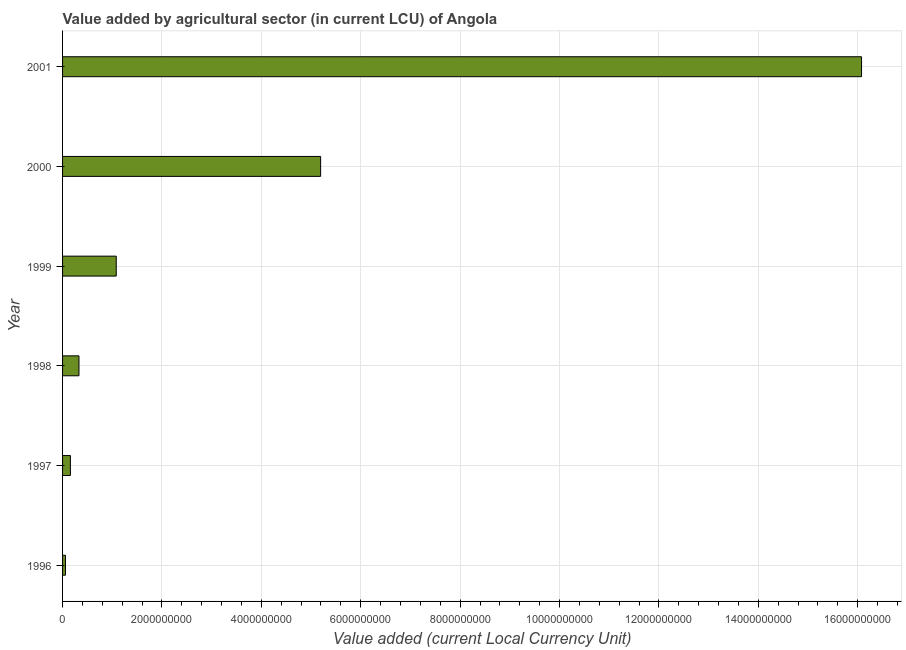Does the graph contain any zero values?
Provide a short and direct response. No. Does the graph contain grids?
Keep it short and to the point. Yes. What is the title of the graph?
Offer a terse response. Value added by agricultural sector (in current LCU) of Angola. What is the label or title of the X-axis?
Give a very brief answer. Value added (current Local Currency Unit). What is the value added by agriculture sector in 2001?
Your response must be concise. 1.61e+1. Across all years, what is the maximum value added by agriculture sector?
Your answer should be very brief. 1.61e+1. Across all years, what is the minimum value added by agriculture sector?
Provide a short and direct response. 5.87e+07. In which year was the value added by agriculture sector minimum?
Your response must be concise. 1996. What is the sum of the value added by agriculture sector?
Provide a succinct answer. 2.29e+1. What is the difference between the value added by agriculture sector in 1998 and 2001?
Your answer should be compact. -1.57e+1. What is the average value added by agriculture sector per year?
Your response must be concise. 3.82e+09. What is the median value added by agriculture sector?
Your answer should be very brief. 7.05e+08. What is the ratio of the value added by agriculture sector in 1996 to that in 1998?
Give a very brief answer. 0.18. What is the difference between the highest and the second highest value added by agriculture sector?
Keep it short and to the point. 1.09e+1. Is the sum of the value added by agriculture sector in 1996 and 2001 greater than the maximum value added by agriculture sector across all years?
Offer a terse response. Yes. What is the difference between the highest and the lowest value added by agriculture sector?
Provide a succinct answer. 1.60e+1. Are the values on the major ticks of X-axis written in scientific E-notation?
Offer a terse response. No. What is the Value added (current Local Currency Unit) of 1996?
Ensure brevity in your answer.  5.87e+07. What is the Value added (current Local Currency Unit) of 1997?
Offer a very short reply. 1.58e+08. What is the Value added (current Local Currency Unit) of 1998?
Offer a very short reply. 3.30e+08. What is the Value added (current Local Currency Unit) in 1999?
Ensure brevity in your answer.  1.08e+09. What is the Value added (current Local Currency Unit) in 2000?
Your answer should be compact. 5.19e+09. What is the Value added (current Local Currency Unit) in 2001?
Provide a short and direct response. 1.61e+1. What is the difference between the Value added (current Local Currency Unit) in 1996 and 1997?
Your answer should be very brief. -9.90e+07. What is the difference between the Value added (current Local Currency Unit) in 1996 and 1998?
Give a very brief answer. -2.71e+08. What is the difference between the Value added (current Local Currency Unit) in 1996 and 1999?
Give a very brief answer. -1.02e+09. What is the difference between the Value added (current Local Currency Unit) in 1996 and 2000?
Offer a terse response. -5.13e+09. What is the difference between the Value added (current Local Currency Unit) in 1996 and 2001?
Offer a terse response. -1.60e+1. What is the difference between the Value added (current Local Currency Unit) in 1997 and 1998?
Provide a short and direct response. -1.72e+08. What is the difference between the Value added (current Local Currency Unit) in 1997 and 1999?
Provide a succinct answer. -9.22e+08. What is the difference between the Value added (current Local Currency Unit) in 1997 and 2000?
Your answer should be compact. -5.03e+09. What is the difference between the Value added (current Local Currency Unit) in 1997 and 2001?
Keep it short and to the point. -1.59e+1. What is the difference between the Value added (current Local Currency Unit) in 1998 and 1999?
Provide a succinct answer. -7.50e+08. What is the difference between the Value added (current Local Currency Unit) in 1998 and 2000?
Provide a short and direct response. -4.86e+09. What is the difference between the Value added (current Local Currency Unit) in 1998 and 2001?
Keep it short and to the point. -1.57e+1. What is the difference between the Value added (current Local Currency Unit) in 1999 and 2000?
Your response must be concise. -4.11e+09. What is the difference between the Value added (current Local Currency Unit) in 1999 and 2001?
Your answer should be compact. -1.50e+1. What is the difference between the Value added (current Local Currency Unit) in 2000 and 2001?
Keep it short and to the point. -1.09e+1. What is the ratio of the Value added (current Local Currency Unit) in 1996 to that in 1997?
Make the answer very short. 0.37. What is the ratio of the Value added (current Local Currency Unit) in 1996 to that in 1998?
Offer a terse response. 0.18. What is the ratio of the Value added (current Local Currency Unit) in 1996 to that in 1999?
Your answer should be very brief. 0.05. What is the ratio of the Value added (current Local Currency Unit) in 1996 to that in 2000?
Your answer should be very brief. 0.01. What is the ratio of the Value added (current Local Currency Unit) in 1996 to that in 2001?
Offer a terse response. 0. What is the ratio of the Value added (current Local Currency Unit) in 1997 to that in 1998?
Make the answer very short. 0.48. What is the ratio of the Value added (current Local Currency Unit) in 1997 to that in 1999?
Offer a very short reply. 0.15. What is the ratio of the Value added (current Local Currency Unit) in 1997 to that in 2000?
Your answer should be compact. 0.03. What is the ratio of the Value added (current Local Currency Unit) in 1997 to that in 2001?
Offer a very short reply. 0.01. What is the ratio of the Value added (current Local Currency Unit) in 1998 to that in 1999?
Provide a short and direct response. 0.31. What is the ratio of the Value added (current Local Currency Unit) in 1998 to that in 2000?
Keep it short and to the point. 0.06. What is the ratio of the Value added (current Local Currency Unit) in 1998 to that in 2001?
Offer a terse response. 0.02. What is the ratio of the Value added (current Local Currency Unit) in 1999 to that in 2000?
Your answer should be compact. 0.21. What is the ratio of the Value added (current Local Currency Unit) in 1999 to that in 2001?
Ensure brevity in your answer.  0.07. What is the ratio of the Value added (current Local Currency Unit) in 2000 to that in 2001?
Make the answer very short. 0.32. 